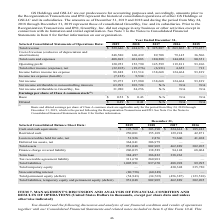From Greensky's financial document, Which years does the table provide information for the company's Selected Consolidated Balance Sheet Data? The document contains multiple relevant values: 2019, 2018, 2017, 2016. From the document: "lected Consolidated Balance Sheet Data: 2019 2018 2017 2016 Cash and cash equivalents $ 195,760 $ 303,390 $ 224,614 $ 185,243 Restricted cash 250,081 ..." Also, What was the amount of restricted cash in 2019? According to the financial document, 250,081 (in thousands). The relevant text states: "760 $ 303,390 $ 224,614 $ 185,243 Restricted cash 250,081 155,109 129,224 42,871 Loan receivables held for sale, net 51,926 2,876 73,606 41,268 Deferred tax..." Also, What was the amount of Cash and cash equivalents in 2016? According to the financial document, 185,243 (in thousands). The relevant text states: "cash equivalents $ 195,760 $ 303,390 $ 224,614 $ 185,243 Restricted cash 250,081 155,109 129,224 42,871 Loan receivables held for sale, net 51,926 2,876 73,..." Also, How many years did Restricted Cash exceed $200,000 thousand? Based on the analysis, there are 1 instances. The counting process: 2019. Also, can you calculate: What was the change in Cash and cash equivalents between 2016 and 2017? Based on the calculation: 224,614-185,243, the result is 39371 (in thousands). This is based on the information: "cash equivalents $ 195,760 $ 303,390 $ 224,614 $ 185,243 Restricted cash 250,081 155,109 129,224 42,871 Loan receivables held for sale, net 51,926 2,876 73, 6 Cash and cash equivalents $ 195,760 $ 303..." The key data points involved are: 185,243, 224,614. Also, can you calculate: What was the percentage change in total assets between 2018 and 2019? To answer this question, I need to perform calculations using the financial data. The calculation is: (951,048-802,905)/802,905, which equals 18.45 (percentage). This is based on the information: "Total assets 951,048 802,905 462,889 302,205 Finance charge reversal liability 206,035 138,589 94,148 68,064 Term loan 3 Total assets 951,048 802,905 462,889 302,205 Finance charge reversal liability ..." The key data points involved are: 802,905, 951,048. 